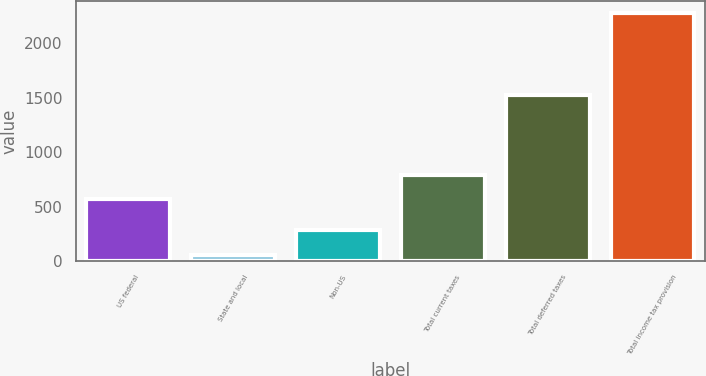Convert chart. <chart><loc_0><loc_0><loc_500><loc_500><bar_chart><fcel>US federal<fcel>State and local<fcel>Non-US<fcel>Total current taxes<fcel>Total deferred taxes<fcel>Total income tax provision<nl><fcel>568<fcel>58<fcel>279.9<fcel>789.9<fcel>1528<fcel>2277<nl></chart> 